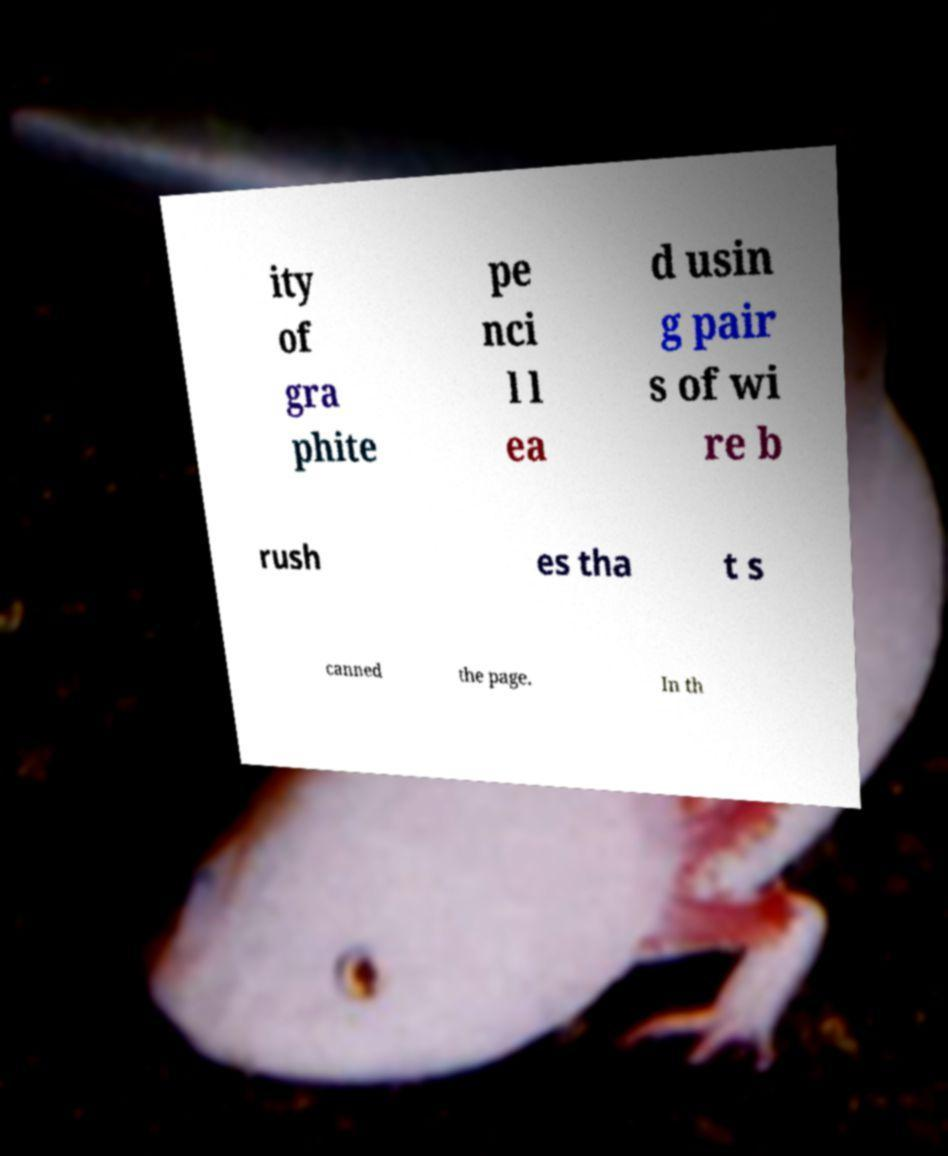Please identify and transcribe the text found in this image. ity of gra phite pe nci l l ea d usin g pair s of wi re b rush es tha t s canned the page. In th 